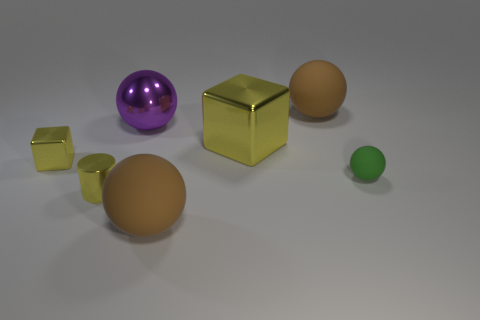Subtract all purple spheres. How many spheres are left? 3 Subtract all green balls. How many balls are left? 3 Add 2 yellow blocks. How many objects exist? 9 Subtract 1 spheres. How many spheres are left? 3 Subtract all green cylinders. How many purple balls are left? 1 Subtract all green rubber spheres. Subtract all tiny yellow metallic cylinders. How many objects are left? 5 Add 6 big yellow shiny objects. How many big yellow shiny objects are left? 7 Add 5 small green spheres. How many small green spheres exist? 6 Subtract 0 cyan blocks. How many objects are left? 7 Subtract all cubes. How many objects are left? 5 